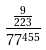<formula> <loc_0><loc_0><loc_500><loc_500>\frac { \frac { 9 } { 2 2 3 } } { 7 7 ^ { 4 5 5 } }</formula> 